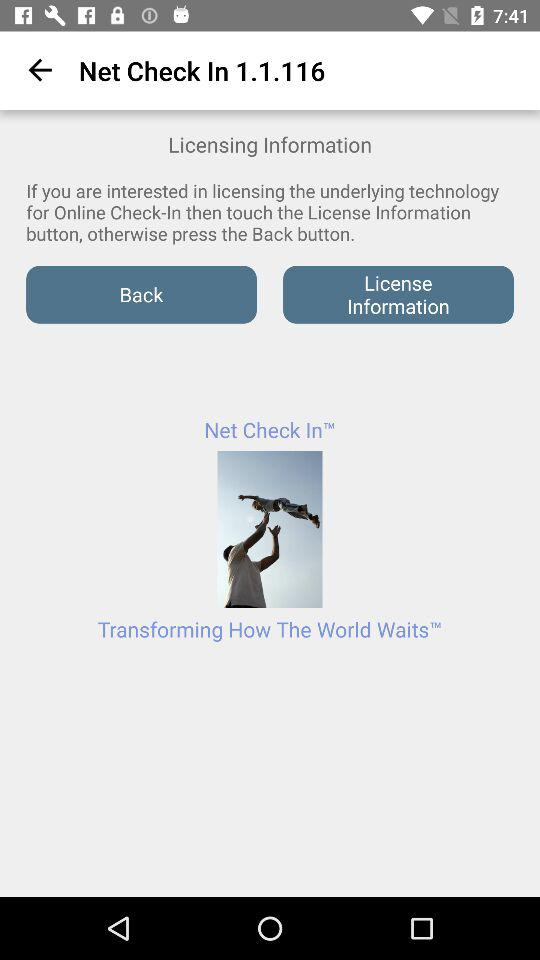Which version of "Net Check" is this? The version is 1.1.116. 